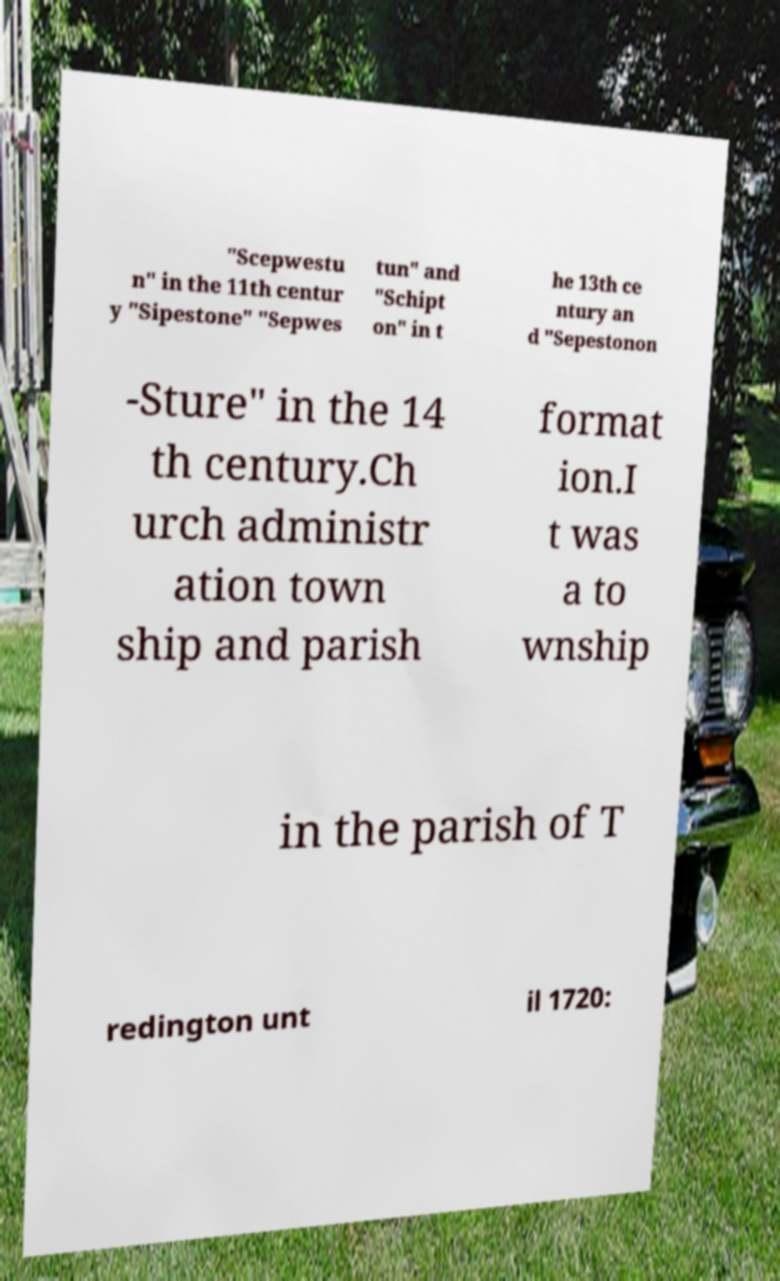For documentation purposes, I need the text within this image transcribed. Could you provide that? "Scepwestu n" in the 11th centur y "Sipestone" "Sepwes tun" and "Schipt on" in t he 13th ce ntury an d "Sepestonon -Sture" in the 14 th century.Ch urch administr ation town ship and parish format ion.I t was a to wnship in the parish of T redington unt il 1720: 